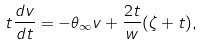<formula> <loc_0><loc_0><loc_500><loc_500>t \frac { d v } { d t } = - \theta _ { \infty } v + \frac { 2 t } { w } ( \zeta + t ) ,</formula> 